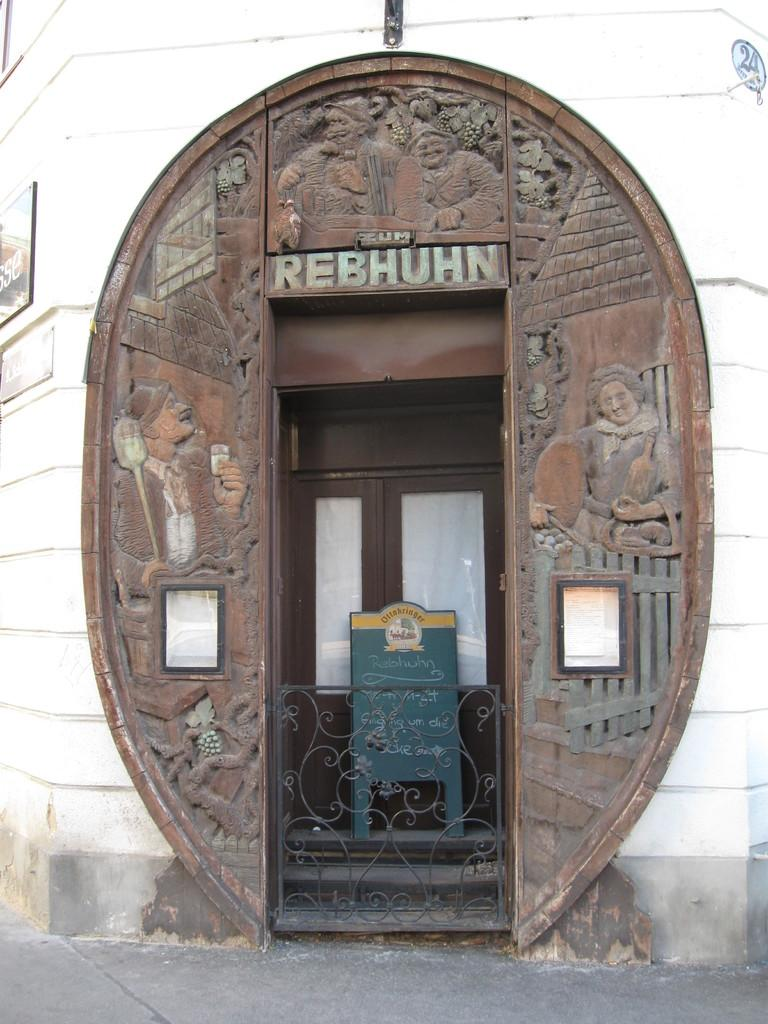What objects are located in the middle of the image? There are metal rods, a board, and doors in the middle of the image. What can be seen on the wall on the left side of the image? There are posters on the wall on the left side of the image. What type of motion can be observed in the image? There is no motion observable in the image; it is a still image. Is there a meeting taking place in the image? There is no indication of a meeting in the image. 